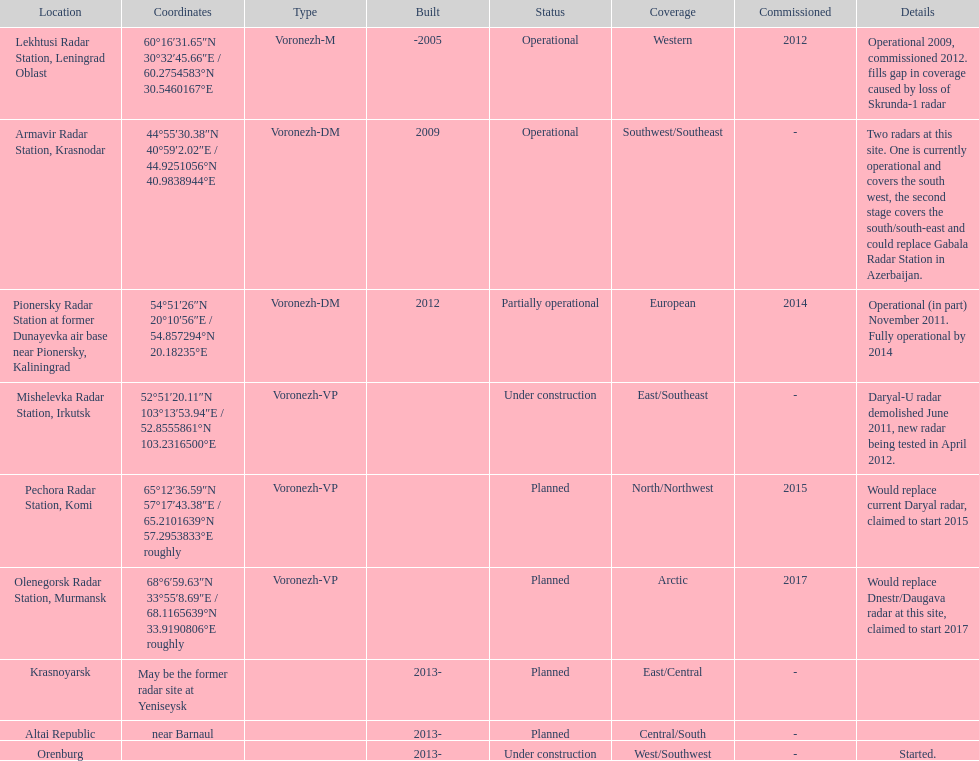What is the only location with a coordination of 60°16&#8242;31.65&#8243;n 30°32&#8242;45.66&#8243;e / 60.2754583°n 30.5460167°e? Lekhtusi Radar Station, Leningrad Oblast. 